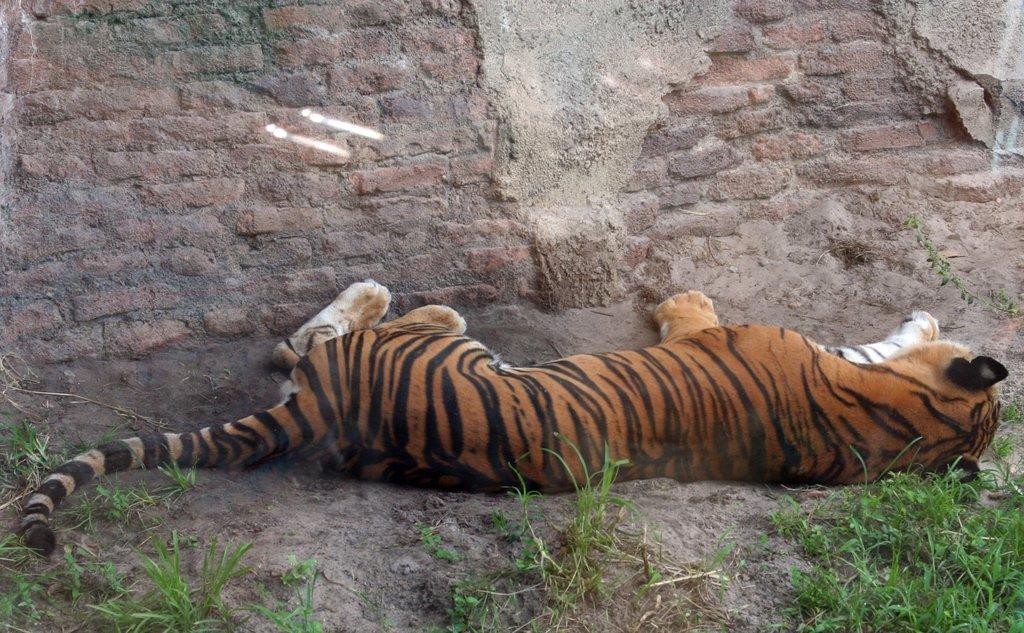Could you give a brief overview of what you see in this image? In the picture I can see a tiger lying on the ground. Here I can see the grass and the brick wall in the background. 